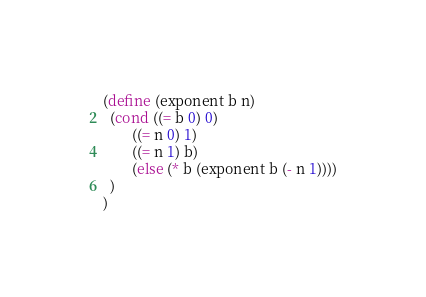Convert code to text. <code><loc_0><loc_0><loc_500><loc_500><_Scheme_>(define (exponent b n)
  (cond ((= b 0) 0)
		((= n 0) 1)
		((= n 1) b)
		(else (* b (exponent b (- n 1))))
  )
)  
</code> 